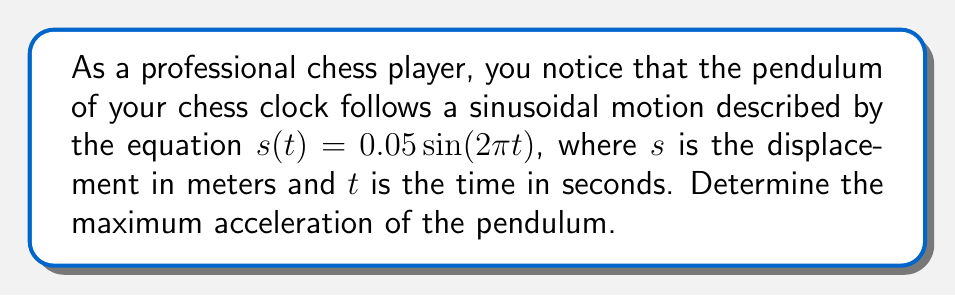Show me your answer to this math problem. To find the maximum acceleration of the pendulum, we need to follow these steps:

1) The displacement function is given as:
   $s(t) = 0.05 \sin(2\pi t)$

2) To find acceleration, we need to differentiate $s(t)$ twice with respect to $t$.

3) First derivative (velocity):
   $v(t) = \frac{ds}{dt} = 0.05 \cdot 2\pi \cos(2\pi t)$
   $v(t) = 0.1\pi \cos(2\pi t)$

4) Second derivative (acceleration):
   $a(t) = \frac{dv}{dt} = 0.1\pi \cdot (-2\pi) \sin(2\pi t)$
   $a(t) = -0.2\pi^2 \sin(2\pi t)$

5) The maximum acceleration occurs when $|\sin(2\pi t)| = 1$, which happens when $2\pi t = \frac{\pi}{2}$ or $\frac{3\pi}{2}$.

6) Therefore, the maximum acceleration is:
   $|a_{max}| = 0.2\pi^2 \approx 1.97$ m/s²
Answer: $1.97$ m/s² 